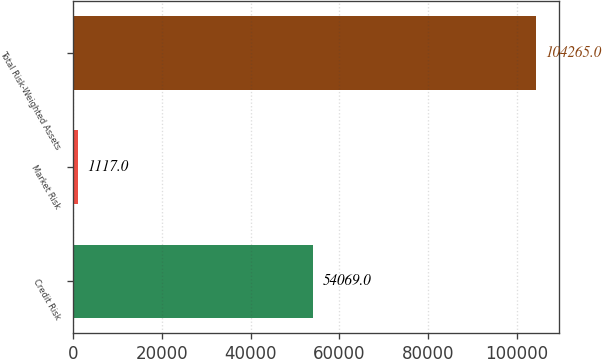<chart> <loc_0><loc_0><loc_500><loc_500><bar_chart><fcel>Credit Risk<fcel>Market Risk<fcel>Total Risk-Weighted Assets<nl><fcel>54069<fcel>1117<fcel>104265<nl></chart> 